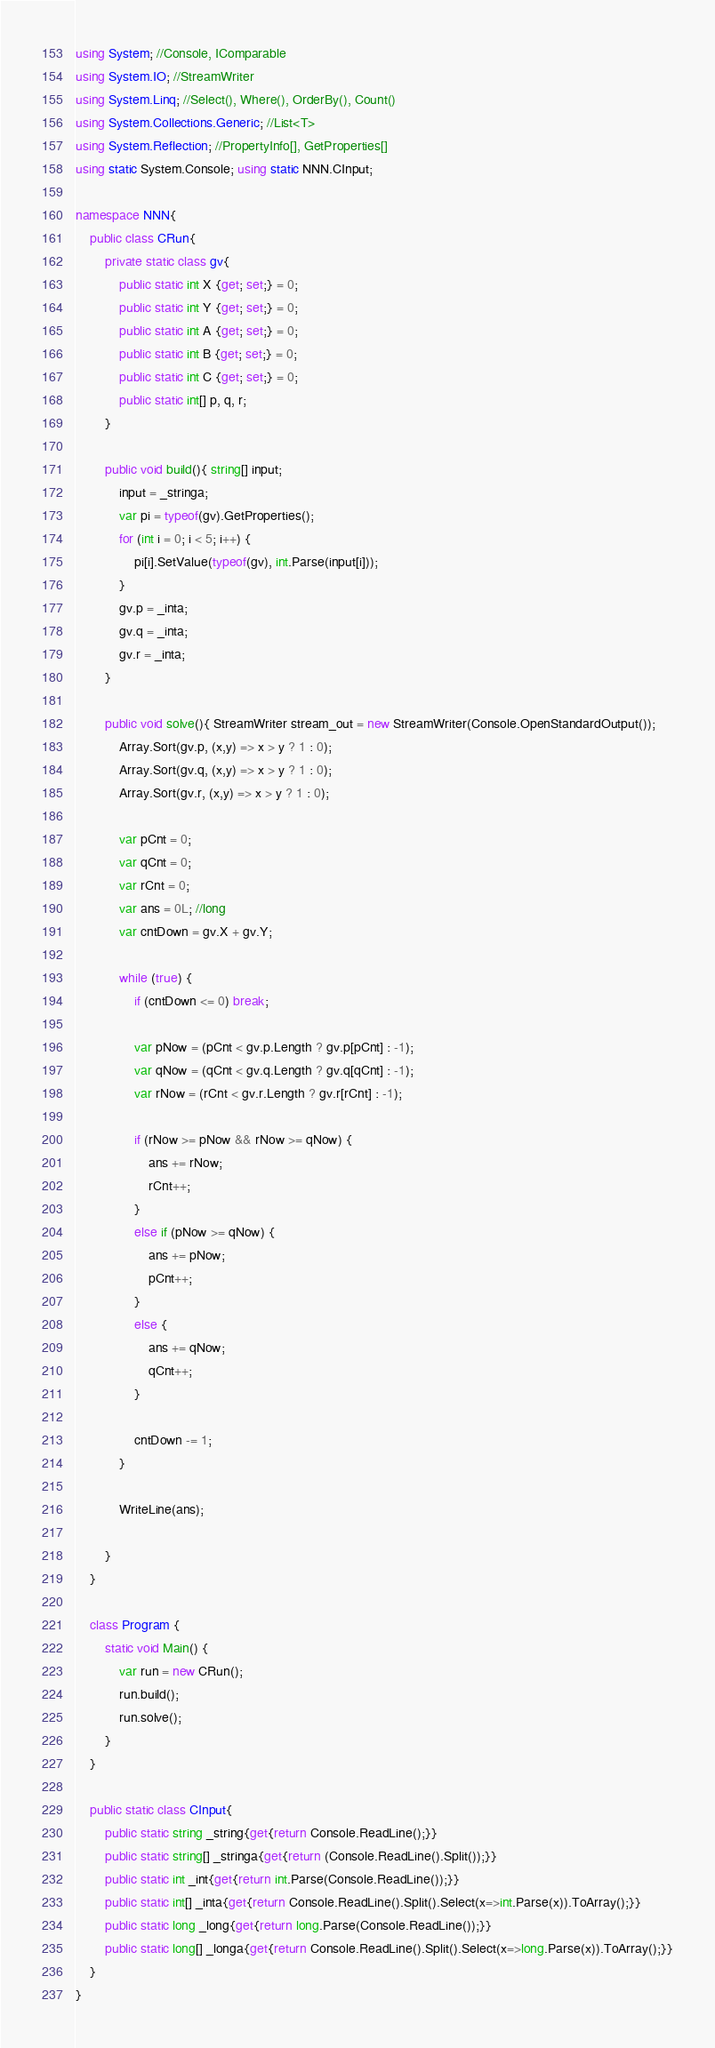<code> <loc_0><loc_0><loc_500><loc_500><_C#_>using System; //Console, IComparable
using System.IO; //StreamWriter 
using System.Linq; //Select(), Where(), OrderBy(), Count()
using System.Collections.Generic; //List<T>
using System.Reflection; //PropertyInfo[], GetProperties[]
using static System.Console; using static NNN.CInput;

namespace NNN{
    public class CRun{
        private static class gv{
            public static int X {get; set;} = 0;
            public static int Y {get; set;} = 0;
            public static int A {get; set;} = 0;
            public static int B {get; set;} = 0;
            public static int C {get; set;} = 0;
            public static int[] p, q, r;
        }
    
        public void build(){ string[] input;
            input = _stringa;
            var pi = typeof(gv).GetProperties();
            for (int i = 0; i < 5; i++) {
                pi[i].SetValue(typeof(gv), int.Parse(input[i]));
            }
            gv.p = _inta;
            gv.q = _inta;
            gv.r = _inta;
        }
        
        public void solve(){ StreamWriter stream_out = new StreamWriter(Console.OpenStandardOutput());
            Array.Sort(gv.p, (x,y) => x > y ? 1 : 0);
            Array.Sort(gv.q, (x,y) => x > y ? 1 : 0);
            Array.Sort(gv.r, (x,y) => x > y ? 1 : 0);
            
            var pCnt = 0;
            var qCnt = 0;
            var rCnt = 0;
            var ans = 0L; //long
            var cntDown = gv.X + gv.Y;
            
            while (true) {
                if (cntDown <= 0) break;
                
                var pNow = (pCnt < gv.p.Length ? gv.p[pCnt] : -1);
                var qNow = (qCnt < gv.q.Length ? gv.q[qCnt] : -1);
                var rNow = (rCnt < gv.r.Length ? gv.r[rCnt] : -1);
                
                if (rNow >= pNow && rNow >= qNow) {
                    ans += rNow;
                    rCnt++;
                }
                else if (pNow >= qNow) {
                    ans += pNow;
                    pCnt++;
                }
                else {
                    ans += qNow;
                    qCnt++;
                }
                
                cntDown -= 1;
            }
            
            WriteLine(ans);
            
        }
    }

    class Program { 
        static void Main() { 
            var run = new CRun();
            run.build();
            run.solve();
        } 
    }

    public static class CInput{
        public static string _string{get{return Console.ReadLine();}}
        public static string[] _stringa{get{return (Console.ReadLine().Split());}}
        public static int _int{get{return int.Parse(Console.ReadLine());}}
        public static int[] _inta{get{return Console.ReadLine().Split().Select(x=>int.Parse(x)).ToArray();}}
        public static long _long{get{return long.Parse(Console.ReadLine());}}
        public static long[] _longa{get{return Console.ReadLine().Split().Select(x=>long.Parse(x)).ToArray();}}
    }
}

</code> 